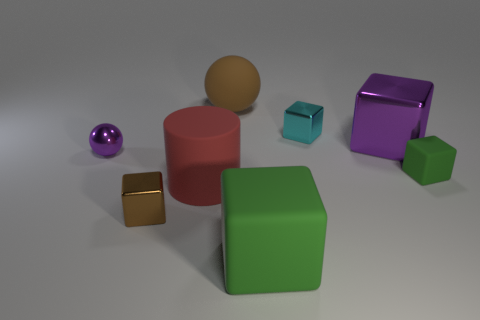Subtract all green cubes. How many cubes are left? 3 Subtract 2 cubes. How many cubes are left? 3 Subtract all tiny rubber blocks. How many blocks are left? 4 Add 1 big green cylinders. How many objects exist? 9 Subtract all red cubes. Subtract all brown spheres. How many cubes are left? 5 Subtract all spheres. How many objects are left? 6 Add 6 large metal blocks. How many large metal blocks exist? 7 Subtract 1 purple spheres. How many objects are left? 7 Subtract all large green shiny cylinders. Subtract all small green cubes. How many objects are left? 7 Add 6 large metallic objects. How many large metallic objects are left? 7 